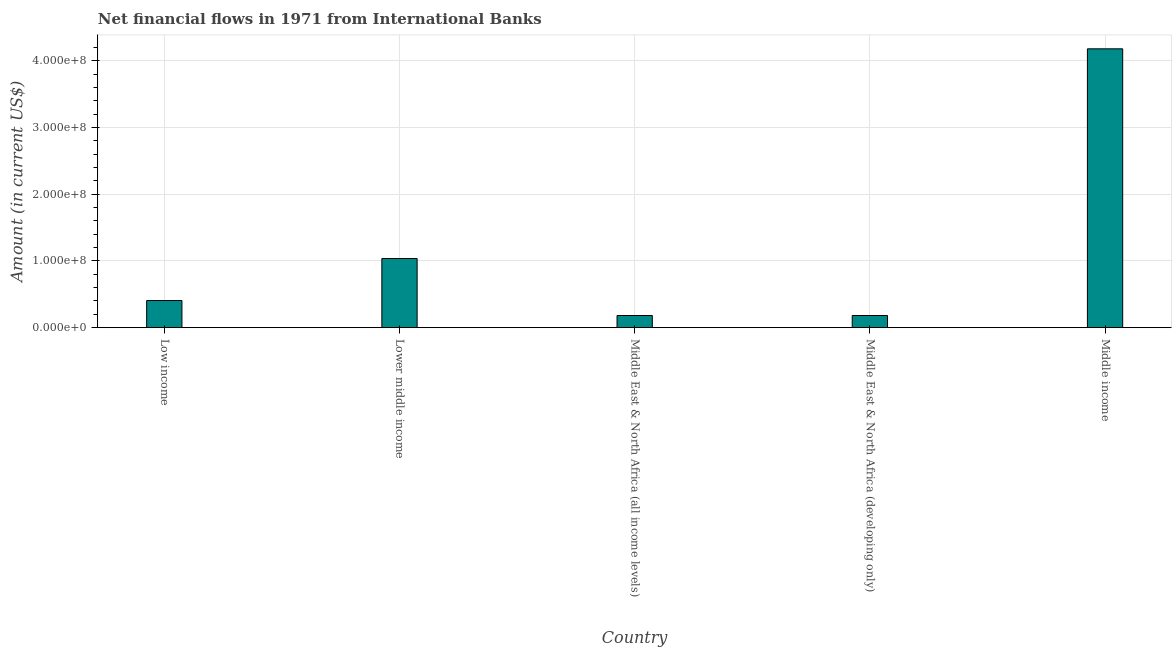Does the graph contain any zero values?
Offer a terse response. No. What is the title of the graph?
Offer a terse response. Net financial flows in 1971 from International Banks. What is the label or title of the X-axis?
Provide a succinct answer. Country. What is the label or title of the Y-axis?
Your response must be concise. Amount (in current US$). What is the net financial flows from ibrd in Low income?
Your answer should be compact. 4.07e+07. Across all countries, what is the maximum net financial flows from ibrd?
Give a very brief answer. 4.18e+08. Across all countries, what is the minimum net financial flows from ibrd?
Your answer should be very brief. 1.82e+07. In which country was the net financial flows from ibrd maximum?
Your response must be concise. Middle income. In which country was the net financial flows from ibrd minimum?
Provide a succinct answer. Middle East & North Africa (all income levels). What is the sum of the net financial flows from ibrd?
Make the answer very short. 5.99e+08. What is the difference between the net financial flows from ibrd in Low income and Lower middle income?
Ensure brevity in your answer.  -6.30e+07. What is the average net financial flows from ibrd per country?
Offer a very short reply. 1.20e+08. What is the median net financial flows from ibrd?
Provide a short and direct response. 4.07e+07. What is the ratio of the net financial flows from ibrd in Middle East & North Africa (all income levels) to that in Middle East & North Africa (developing only)?
Your response must be concise. 1. Is the net financial flows from ibrd in Low income less than that in Middle East & North Africa (developing only)?
Keep it short and to the point. No. Is the difference between the net financial flows from ibrd in Middle East & North Africa (all income levels) and Middle income greater than the difference between any two countries?
Your answer should be very brief. Yes. What is the difference between the highest and the second highest net financial flows from ibrd?
Provide a succinct answer. 3.14e+08. What is the difference between the highest and the lowest net financial flows from ibrd?
Give a very brief answer. 4.00e+08. In how many countries, is the net financial flows from ibrd greater than the average net financial flows from ibrd taken over all countries?
Your answer should be compact. 1. How many bars are there?
Your answer should be very brief. 5. How many countries are there in the graph?
Your answer should be compact. 5. What is the difference between two consecutive major ticks on the Y-axis?
Your answer should be compact. 1.00e+08. Are the values on the major ticks of Y-axis written in scientific E-notation?
Provide a short and direct response. Yes. What is the Amount (in current US$) of Low income?
Your answer should be compact. 4.07e+07. What is the Amount (in current US$) in Lower middle income?
Offer a very short reply. 1.04e+08. What is the Amount (in current US$) in Middle East & North Africa (all income levels)?
Offer a very short reply. 1.82e+07. What is the Amount (in current US$) of Middle East & North Africa (developing only)?
Provide a short and direct response. 1.82e+07. What is the Amount (in current US$) in Middle income?
Ensure brevity in your answer.  4.18e+08. What is the difference between the Amount (in current US$) in Low income and Lower middle income?
Your answer should be very brief. -6.30e+07. What is the difference between the Amount (in current US$) in Low income and Middle East & North Africa (all income levels)?
Your answer should be very brief. 2.24e+07. What is the difference between the Amount (in current US$) in Low income and Middle East & North Africa (developing only)?
Make the answer very short. 2.24e+07. What is the difference between the Amount (in current US$) in Low income and Middle income?
Make the answer very short. -3.77e+08. What is the difference between the Amount (in current US$) in Lower middle income and Middle East & North Africa (all income levels)?
Your response must be concise. 8.54e+07. What is the difference between the Amount (in current US$) in Lower middle income and Middle East & North Africa (developing only)?
Keep it short and to the point. 8.54e+07. What is the difference between the Amount (in current US$) in Lower middle income and Middle income?
Provide a short and direct response. -3.14e+08. What is the difference between the Amount (in current US$) in Middle East & North Africa (all income levels) and Middle East & North Africa (developing only)?
Your answer should be compact. 0. What is the difference between the Amount (in current US$) in Middle East & North Africa (all income levels) and Middle income?
Offer a terse response. -4.00e+08. What is the difference between the Amount (in current US$) in Middle East & North Africa (developing only) and Middle income?
Offer a very short reply. -4.00e+08. What is the ratio of the Amount (in current US$) in Low income to that in Lower middle income?
Provide a succinct answer. 0.39. What is the ratio of the Amount (in current US$) in Low income to that in Middle East & North Africa (all income levels)?
Keep it short and to the point. 2.23. What is the ratio of the Amount (in current US$) in Low income to that in Middle East & North Africa (developing only)?
Provide a succinct answer. 2.23. What is the ratio of the Amount (in current US$) in Low income to that in Middle income?
Your response must be concise. 0.1. What is the ratio of the Amount (in current US$) in Lower middle income to that in Middle East & North Africa (all income levels)?
Offer a very short reply. 5.68. What is the ratio of the Amount (in current US$) in Lower middle income to that in Middle East & North Africa (developing only)?
Ensure brevity in your answer.  5.68. What is the ratio of the Amount (in current US$) in Lower middle income to that in Middle income?
Keep it short and to the point. 0.25. What is the ratio of the Amount (in current US$) in Middle East & North Africa (all income levels) to that in Middle income?
Provide a succinct answer. 0.04. What is the ratio of the Amount (in current US$) in Middle East & North Africa (developing only) to that in Middle income?
Provide a short and direct response. 0.04. 